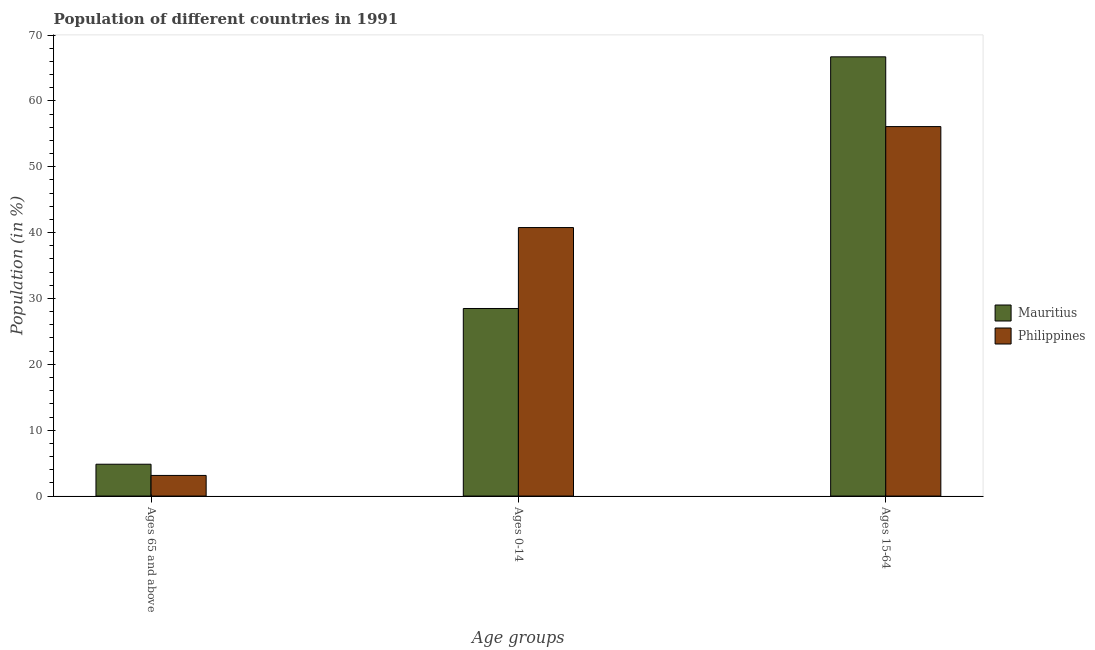How many bars are there on the 2nd tick from the left?
Offer a terse response. 2. What is the label of the 3rd group of bars from the left?
Ensure brevity in your answer.  Ages 15-64. What is the percentage of population within the age-group 0-14 in Philippines?
Ensure brevity in your answer.  40.77. Across all countries, what is the maximum percentage of population within the age-group 15-64?
Provide a short and direct response. 66.69. Across all countries, what is the minimum percentage of population within the age-group 0-14?
Keep it short and to the point. 28.48. In which country was the percentage of population within the age-group 0-14 maximum?
Your answer should be very brief. Philippines. In which country was the percentage of population within the age-group 0-14 minimum?
Ensure brevity in your answer.  Mauritius. What is the total percentage of population within the age-group of 65 and above in the graph?
Provide a short and direct response. 7.97. What is the difference between the percentage of population within the age-group of 65 and above in Mauritius and that in Philippines?
Make the answer very short. 1.7. What is the difference between the percentage of population within the age-group 15-64 in Mauritius and the percentage of population within the age-group 0-14 in Philippines?
Make the answer very short. 25.92. What is the average percentage of population within the age-group 15-64 per country?
Your answer should be very brief. 61.39. What is the difference between the percentage of population within the age-group 15-64 and percentage of population within the age-group 0-14 in Mauritius?
Keep it short and to the point. 38.21. What is the ratio of the percentage of population within the age-group 0-14 in Philippines to that in Mauritius?
Give a very brief answer. 1.43. Is the percentage of population within the age-group 15-64 in Philippines less than that in Mauritius?
Provide a short and direct response. Yes. Is the difference between the percentage of population within the age-group 0-14 in Mauritius and Philippines greater than the difference between the percentage of population within the age-group of 65 and above in Mauritius and Philippines?
Keep it short and to the point. No. What is the difference between the highest and the second highest percentage of population within the age-group 0-14?
Your answer should be very brief. 12.29. What is the difference between the highest and the lowest percentage of population within the age-group 15-64?
Your answer should be compact. 10.59. In how many countries, is the percentage of population within the age-group 15-64 greater than the average percentage of population within the age-group 15-64 taken over all countries?
Provide a short and direct response. 1. What does the 1st bar from the left in Ages 0-14 represents?
Your answer should be compact. Mauritius. What does the 2nd bar from the right in Ages 15-64 represents?
Provide a short and direct response. Mauritius. Are all the bars in the graph horizontal?
Your answer should be very brief. No. How many countries are there in the graph?
Provide a short and direct response. 2. What is the difference between two consecutive major ticks on the Y-axis?
Give a very brief answer. 10. Are the values on the major ticks of Y-axis written in scientific E-notation?
Ensure brevity in your answer.  No. Does the graph contain any zero values?
Your answer should be very brief. No. Does the graph contain grids?
Give a very brief answer. No. How many legend labels are there?
Offer a terse response. 2. What is the title of the graph?
Offer a very short reply. Population of different countries in 1991. What is the label or title of the X-axis?
Your response must be concise. Age groups. What is the Population (in %) in Mauritius in Ages 65 and above?
Your answer should be very brief. 4.83. What is the Population (in %) in Philippines in Ages 65 and above?
Your response must be concise. 3.13. What is the Population (in %) in Mauritius in Ages 0-14?
Offer a very short reply. 28.48. What is the Population (in %) of Philippines in Ages 0-14?
Your answer should be very brief. 40.77. What is the Population (in %) in Mauritius in Ages 15-64?
Ensure brevity in your answer.  66.69. What is the Population (in %) in Philippines in Ages 15-64?
Ensure brevity in your answer.  56.1. Across all Age groups, what is the maximum Population (in %) in Mauritius?
Your answer should be very brief. 66.69. Across all Age groups, what is the maximum Population (in %) in Philippines?
Offer a terse response. 56.1. Across all Age groups, what is the minimum Population (in %) in Mauritius?
Ensure brevity in your answer.  4.83. Across all Age groups, what is the minimum Population (in %) of Philippines?
Make the answer very short. 3.13. What is the total Population (in %) in Mauritius in the graph?
Your answer should be compact. 100. What is the total Population (in %) in Philippines in the graph?
Offer a terse response. 100. What is the difference between the Population (in %) of Mauritius in Ages 65 and above and that in Ages 0-14?
Provide a succinct answer. -23.64. What is the difference between the Population (in %) of Philippines in Ages 65 and above and that in Ages 0-14?
Keep it short and to the point. -37.63. What is the difference between the Population (in %) of Mauritius in Ages 65 and above and that in Ages 15-64?
Your response must be concise. -61.85. What is the difference between the Population (in %) in Philippines in Ages 65 and above and that in Ages 15-64?
Provide a short and direct response. -52.97. What is the difference between the Population (in %) in Mauritius in Ages 0-14 and that in Ages 15-64?
Your answer should be compact. -38.21. What is the difference between the Population (in %) of Philippines in Ages 0-14 and that in Ages 15-64?
Provide a succinct answer. -15.33. What is the difference between the Population (in %) in Mauritius in Ages 65 and above and the Population (in %) in Philippines in Ages 0-14?
Your answer should be compact. -35.93. What is the difference between the Population (in %) in Mauritius in Ages 65 and above and the Population (in %) in Philippines in Ages 15-64?
Offer a very short reply. -51.27. What is the difference between the Population (in %) of Mauritius in Ages 0-14 and the Population (in %) of Philippines in Ages 15-64?
Offer a terse response. -27.62. What is the average Population (in %) in Mauritius per Age groups?
Give a very brief answer. 33.33. What is the average Population (in %) of Philippines per Age groups?
Give a very brief answer. 33.33. What is the difference between the Population (in %) of Mauritius and Population (in %) of Philippines in Ages 65 and above?
Offer a very short reply. 1.7. What is the difference between the Population (in %) of Mauritius and Population (in %) of Philippines in Ages 0-14?
Keep it short and to the point. -12.29. What is the difference between the Population (in %) in Mauritius and Population (in %) in Philippines in Ages 15-64?
Your answer should be compact. 10.59. What is the ratio of the Population (in %) in Mauritius in Ages 65 and above to that in Ages 0-14?
Offer a terse response. 0.17. What is the ratio of the Population (in %) of Philippines in Ages 65 and above to that in Ages 0-14?
Make the answer very short. 0.08. What is the ratio of the Population (in %) in Mauritius in Ages 65 and above to that in Ages 15-64?
Your response must be concise. 0.07. What is the ratio of the Population (in %) in Philippines in Ages 65 and above to that in Ages 15-64?
Offer a terse response. 0.06. What is the ratio of the Population (in %) of Mauritius in Ages 0-14 to that in Ages 15-64?
Your answer should be compact. 0.43. What is the ratio of the Population (in %) in Philippines in Ages 0-14 to that in Ages 15-64?
Your answer should be compact. 0.73. What is the difference between the highest and the second highest Population (in %) of Mauritius?
Offer a terse response. 38.21. What is the difference between the highest and the second highest Population (in %) of Philippines?
Your answer should be compact. 15.33. What is the difference between the highest and the lowest Population (in %) in Mauritius?
Provide a succinct answer. 61.85. What is the difference between the highest and the lowest Population (in %) of Philippines?
Give a very brief answer. 52.97. 